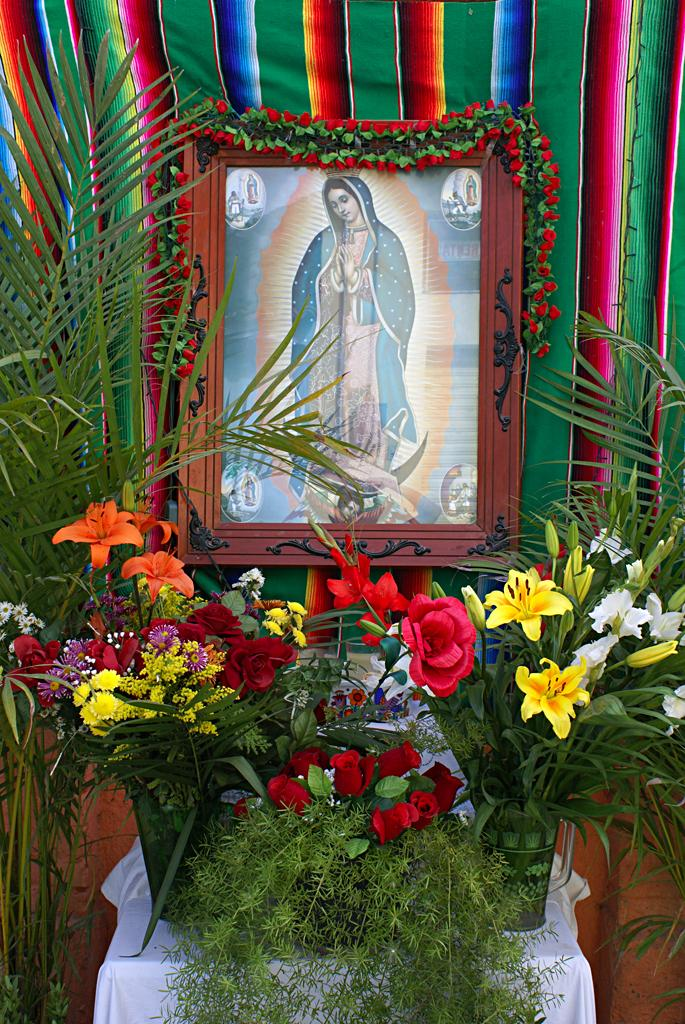What type of flora can be seen in the image? There are flowers in the image. What type of furniture is present in the image? There is a table in the image. What is hanging on the photo frame in the image? There is a garland on the photo frame in the image. What type of decorative lighting is visible in the background of the image? There is a light rope in the background of the image. What type of fabric is present in the background of the image? There is a cloth in the background of the image. How many babies are crawling on the table in the image? There are no babies present in the image; it features flowers, a table, a photo frame with a garland, a light rope, and a cloth. What type of oil is being used to light the light rope in the image? There is no oil present in the image; the light rope is likely an electric string of lights. 